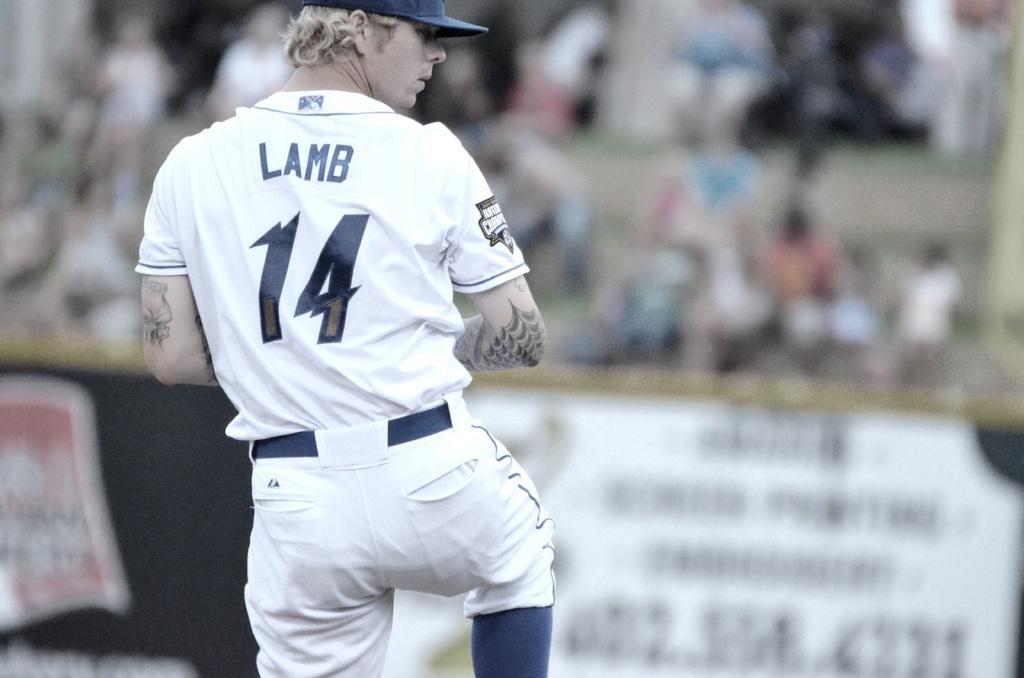<image>
Present a compact description of the photo's key features. A baseball pitcher with Lamb 14 on their shirt. 